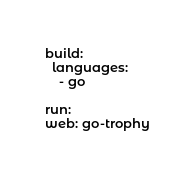Convert code to text. <code><loc_0><loc_0><loc_500><loc_500><_YAML_>build:
  languages:
    - go

run:
web: go-trophy
</code> 